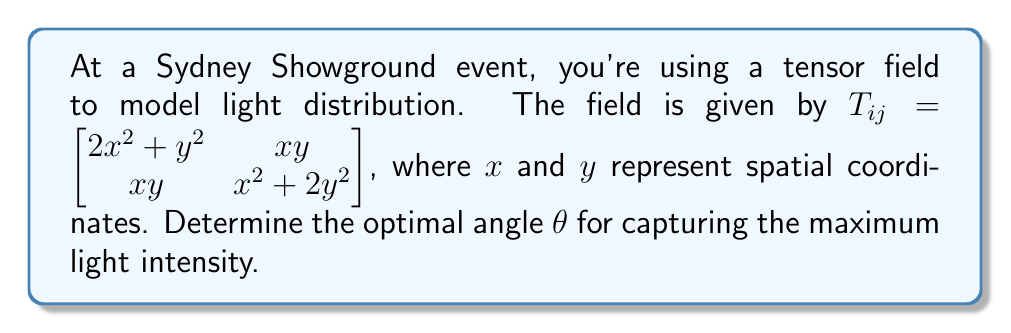Solve this math problem. To find the optimal angle for capturing maximum light intensity, we need to follow these steps:

1) The light intensity is given by the eigenvalues of the tensor. We need to find the maximum eigenvalue.

2) The characteristic equation is:
   $$\det(T_{ij} - \lambda I) = 0$$
   $$\begin{vmatrix} 
   2x^2 + y^2 - \lambda & xy \\
   xy & x^2 + 2y^2 - \lambda
   \end{vmatrix} = 0$$

3) Expanding the determinant:
   $$(2x^2 + y^2 - \lambda)(x^2 + 2y^2 - \lambda) - x^2y^2 = 0$$
   $$2x^4 + 4x^2y^2 + 2x^2y^2 + y^4 - \lambda(3x^2 + 3y^2) + \lambda^2 - x^2y^2 = 0$$
   $$2x^4 + 5x^2y^2 + y^4 - \lambda(3x^2 + 3y^2) + \lambda^2 = 0$$

4) The largest eigenvalue is:
   $$\lambda_{max} = \frac{3(x^2 + y^2) + \sqrt{9(x^2 + y^2)^2 - 8(2x^4 + 5x^2y^2 + y^4)}}{2}$$

5) The eigenvector corresponding to this eigenvalue gives the direction of maximum light intensity. Let's call this eigenvector $(v_1, v_2)$.

6) The optimal angle $\theta$ is given by:
   $$\theta = \arctan(\frac{v_2}{v_1})$$

7) The components of the eigenvector are:
   $$v_1 = xy$$
   $$v_2 = \lambda_{max} - (2x^2 + y^2)$$

8) Therefore, the optimal angle is:
   $$\theta = \arctan(\frac{\lambda_{max} - (2x^2 + y^2)}{xy})$$

This angle $\theta$ will give the optimal direction for capturing the maximum light intensity at any point $(x,y)$ in the field.
Answer: $\theta = \arctan(\frac{\lambda_{max} - (2x^2 + y^2)}{xy})$, where $\lambda_{max} = \frac{3(x^2 + y^2) + \sqrt{9(x^2 + y^2)^2 - 8(2x^4 + 5x^2y^2 + y^4)}}{2}$ 